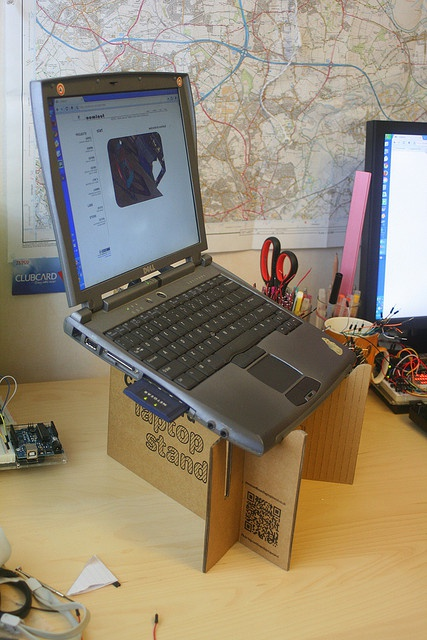Describe the objects in this image and their specific colors. I can see laptop in lightgray, gray, black, and darkgray tones, tv in lightgray, darkgray, gray, and black tones, tv in lightgray, white, black, and lightblue tones, cup in lightgray, brown, tan, and black tones, and scissors in lightgray, black, brown, red, and maroon tones in this image. 